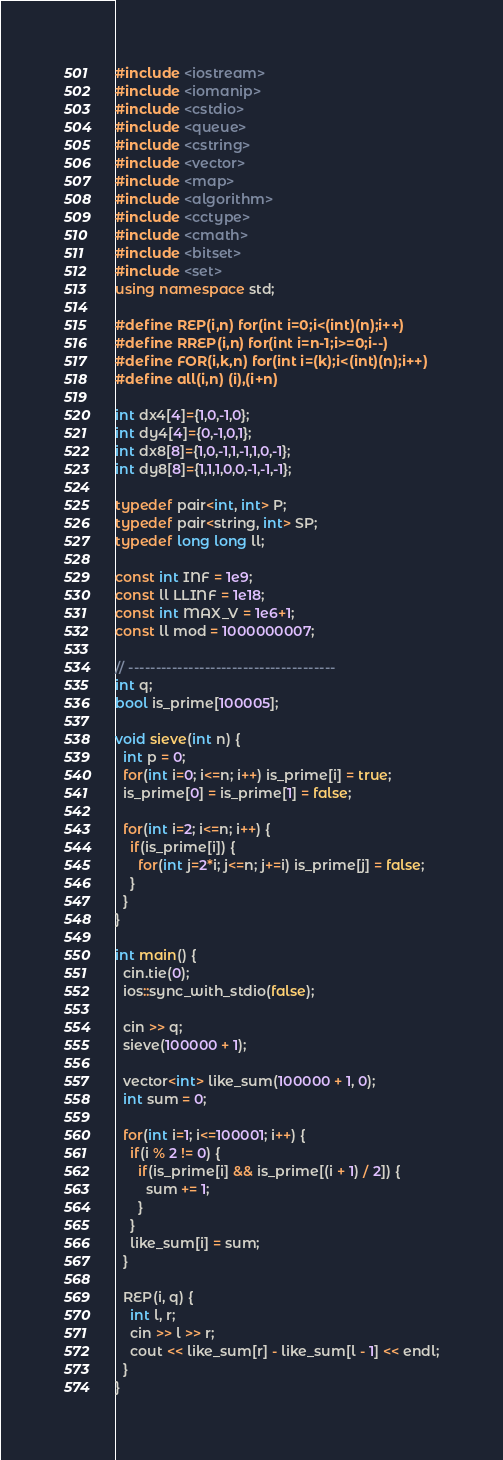Convert code to text. <code><loc_0><loc_0><loc_500><loc_500><_C++_>#include <iostream>
#include <iomanip>
#include <cstdio>
#include <queue>
#include <cstring>
#include <vector>
#include <map>
#include <algorithm>
#include <cctype>
#include <cmath>
#include <bitset>
#include <set>
using namespace std;

#define REP(i,n) for(int i=0;i<(int)(n);i++)
#define RREP(i,n) for(int i=n-1;i>=0;i--)
#define FOR(i,k,n) for(int i=(k);i<(int)(n);i++)
#define all(i,n) (i),(i+n)

int dx4[4]={1,0,-1,0};
int dy4[4]={0,-1,0,1};
int dx8[8]={1,0,-1,1,-1,1,0,-1};
int dy8[8]={1,1,1,0,0,-1,-1,-1};

typedef pair<int, int> P;
typedef pair<string, int> SP;
typedef long long ll;

const int INF = 1e9;
const ll LLINF = 1e18;
const int MAX_V = 1e6+1;
const ll mod = 1000000007;

// --------------------------------------
int q;
bool is_prime[100005];

void sieve(int n) {
  int p = 0;
  for(int i=0; i<=n; i++) is_prime[i] = true;
  is_prime[0] = is_prime[1] = false;

  for(int i=2; i<=n; i++) {
    if(is_prime[i]) {
      for(int j=2*i; j<=n; j+=i) is_prime[j] = false;
    }
  }
}

int main() {
  cin.tie(0);
  ios::sync_with_stdio(false);

  cin >> q;
  sieve(100000 + 1);

  vector<int> like_sum(100000 + 1, 0);
  int sum = 0;

  for(int i=1; i<=100001; i++) {
    if(i % 2 != 0) {
      if(is_prime[i] && is_prime[(i + 1) / 2]) {
        sum += 1;
      }
    }
    like_sum[i] = sum;
  }

  REP(i, q) {
    int l, r;
    cin >> l >> r;
    cout << like_sum[r] - like_sum[l - 1] << endl;
  }
}
</code> 